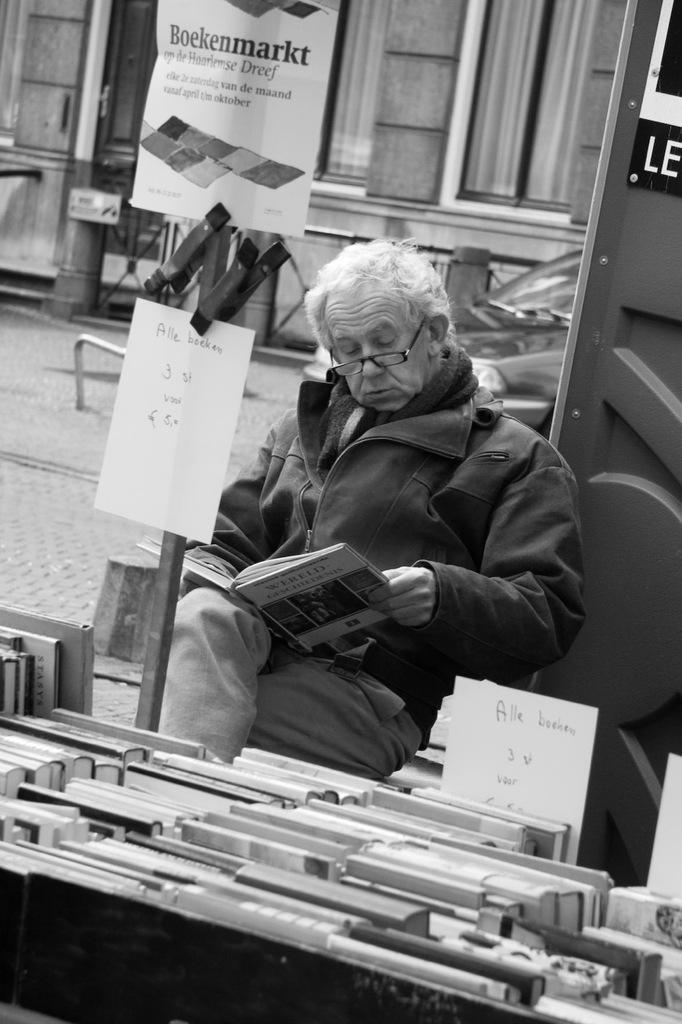Could you give a brief overview of what you see in this image? In this image there is a man sitting in the chair and reading the book. In front of him there are so many books kept in the rack. In the middle there is a wooden stick to which there is a poster. In the background there is a building with the glass windows. There is a car behind the person. 